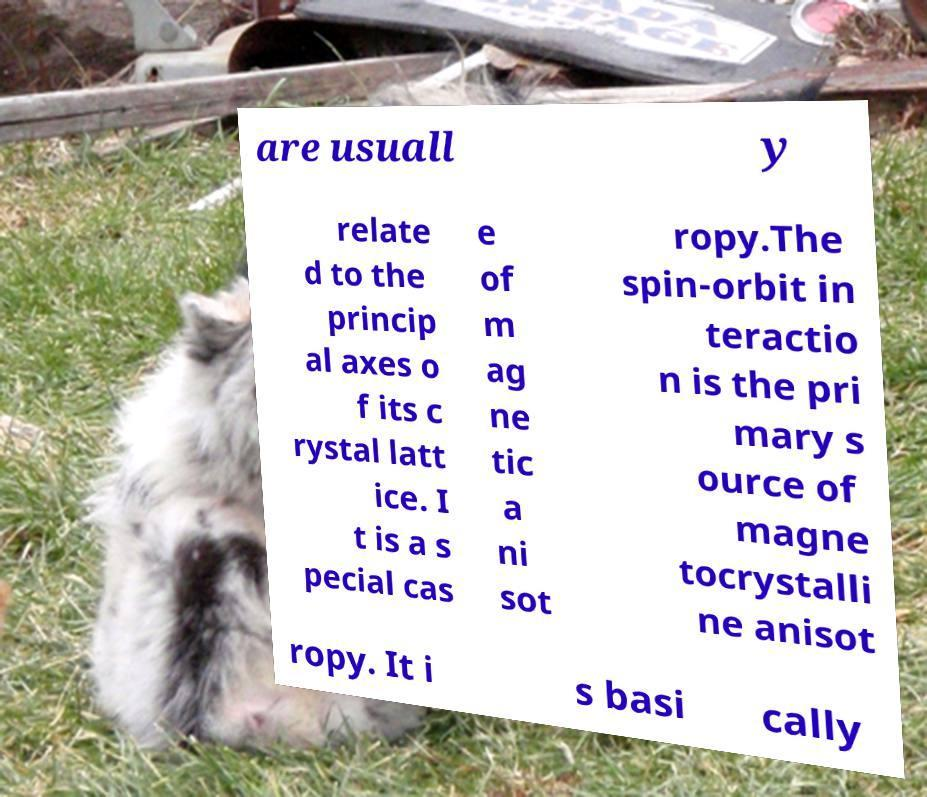For documentation purposes, I need the text within this image transcribed. Could you provide that? are usuall y relate d to the princip al axes o f its c rystal latt ice. I t is a s pecial cas e of m ag ne tic a ni sot ropy.The spin-orbit in teractio n is the pri mary s ource of magne tocrystalli ne anisot ropy. It i s basi cally 